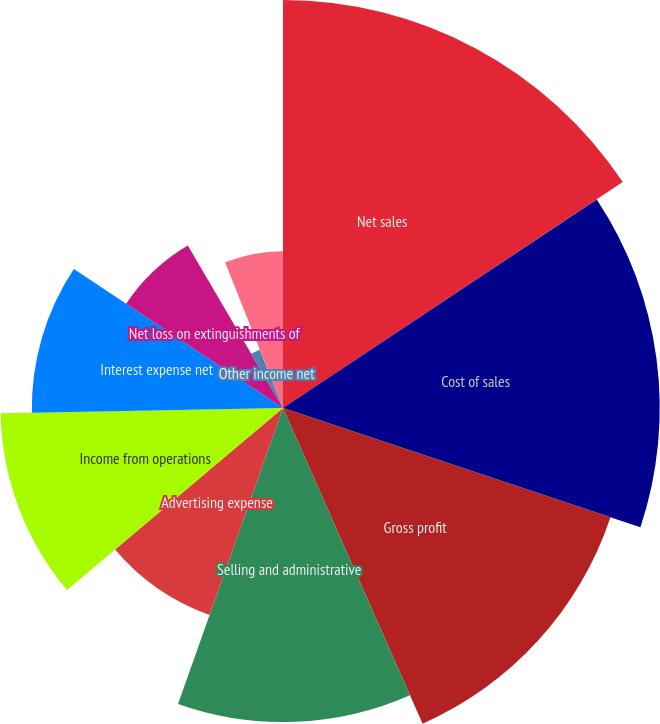Convert chart. <chart><loc_0><loc_0><loc_500><loc_500><pie_chart><fcel>Net sales<fcel>Cost of sales<fcel>Gross profit<fcel>Selling and administrative<fcel>Advertising expense<fcel>Income from operations<fcel>Interest expense net<fcel>Net loss on extinguishments of<fcel>Other income net<fcel>Income before income taxes<nl><fcel>15.66%<fcel>14.46%<fcel>13.25%<fcel>12.05%<fcel>8.43%<fcel>10.84%<fcel>9.64%<fcel>7.23%<fcel>2.41%<fcel>6.02%<nl></chart> 